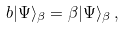<formula> <loc_0><loc_0><loc_500><loc_500>b | \Psi \rangle _ { \beta } = \beta | \Psi \rangle _ { \beta } \, ,</formula> 